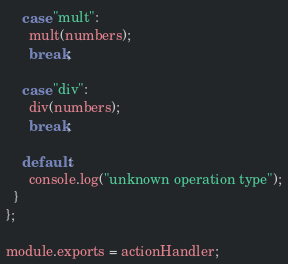Convert code to text. <code><loc_0><loc_0><loc_500><loc_500><_JavaScript_>    case "mult":
      mult(numbers);
      break;

    case "div":
      div(numbers);
      break;

    default:
      console.log("unknown operation type");
  }
};

module.exports = actionHandler;
</code> 